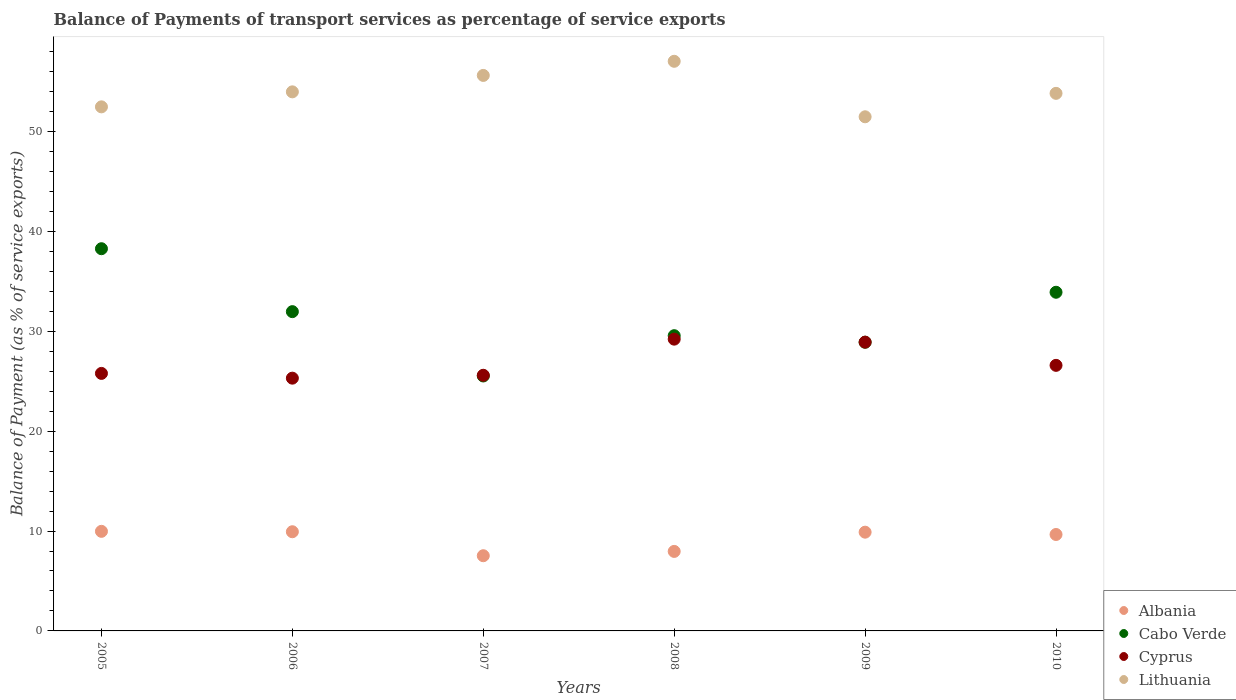How many different coloured dotlines are there?
Ensure brevity in your answer.  4. What is the balance of payments of transport services in Lithuania in 2005?
Offer a terse response. 52.47. Across all years, what is the maximum balance of payments of transport services in Cyprus?
Make the answer very short. 29.21. Across all years, what is the minimum balance of payments of transport services in Albania?
Your answer should be compact. 7.53. In which year was the balance of payments of transport services in Albania minimum?
Offer a very short reply. 2007. What is the total balance of payments of transport services in Cabo Verde in the graph?
Ensure brevity in your answer.  188.13. What is the difference between the balance of payments of transport services in Cyprus in 2006 and that in 2010?
Ensure brevity in your answer.  -1.28. What is the difference between the balance of payments of transport services in Cyprus in 2008 and the balance of payments of transport services in Albania in 2010?
Keep it short and to the point. 19.56. What is the average balance of payments of transport services in Cabo Verde per year?
Your answer should be very brief. 31.35. In the year 2010, what is the difference between the balance of payments of transport services in Cabo Verde and balance of payments of transport services in Cyprus?
Give a very brief answer. 7.32. In how many years, is the balance of payments of transport services in Cyprus greater than 54 %?
Provide a succinct answer. 0. What is the ratio of the balance of payments of transport services in Lithuania in 2005 to that in 2007?
Your answer should be compact. 0.94. Is the balance of payments of transport services in Cyprus in 2006 less than that in 2007?
Your response must be concise. Yes. What is the difference between the highest and the second highest balance of payments of transport services in Albania?
Make the answer very short. 0.04. What is the difference between the highest and the lowest balance of payments of transport services in Albania?
Your answer should be very brief. 2.44. Does the balance of payments of transport services in Lithuania monotonically increase over the years?
Give a very brief answer. No. Is the balance of payments of transport services in Albania strictly greater than the balance of payments of transport services in Cabo Verde over the years?
Your answer should be compact. No. How many dotlines are there?
Make the answer very short. 4. How many years are there in the graph?
Your response must be concise. 6. What is the difference between two consecutive major ticks on the Y-axis?
Your answer should be very brief. 10. Does the graph contain any zero values?
Your response must be concise. No. Does the graph contain grids?
Your answer should be compact. No. How many legend labels are there?
Your answer should be very brief. 4. What is the title of the graph?
Offer a terse response. Balance of Payments of transport services as percentage of service exports. Does "Antigua and Barbuda" appear as one of the legend labels in the graph?
Make the answer very short. No. What is the label or title of the Y-axis?
Offer a very short reply. Balance of Payment (as % of service exports). What is the Balance of Payment (as % of service exports) of Albania in 2005?
Keep it short and to the point. 9.97. What is the Balance of Payment (as % of service exports) of Cabo Verde in 2005?
Offer a very short reply. 38.27. What is the Balance of Payment (as % of service exports) in Cyprus in 2005?
Make the answer very short. 25.78. What is the Balance of Payment (as % of service exports) of Lithuania in 2005?
Keep it short and to the point. 52.47. What is the Balance of Payment (as % of service exports) of Albania in 2006?
Your response must be concise. 9.93. What is the Balance of Payment (as % of service exports) of Cabo Verde in 2006?
Offer a very short reply. 31.97. What is the Balance of Payment (as % of service exports) of Cyprus in 2006?
Make the answer very short. 25.31. What is the Balance of Payment (as % of service exports) of Lithuania in 2006?
Your answer should be very brief. 53.97. What is the Balance of Payment (as % of service exports) in Albania in 2007?
Keep it short and to the point. 7.53. What is the Balance of Payment (as % of service exports) in Cabo Verde in 2007?
Offer a terse response. 25.53. What is the Balance of Payment (as % of service exports) in Cyprus in 2007?
Keep it short and to the point. 25.6. What is the Balance of Payment (as % of service exports) in Lithuania in 2007?
Your response must be concise. 55.62. What is the Balance of Payment (as % of service exports) in Albania in 2008?
Offer a terse response. 7.96. What is the Balance of Payment (as % of service exports) in Cabo Verde in 2008?
Provide a succinct answer. 29.56. What is the Balance of Payment (as % of service exports) of Cyprus in 2008?
Ensure brevity in your answer.  29.21. What is the Balance of Payment (as % of service exports) of Lithuania in 2008?
Offer a terse response. 57.03. What is the Balance of Payment (as % of service exports) in Albania in 2009?
Your answer should be compact. 9.89. What is the Balance of Payment (as % of service exports) of Cabo Verde in 2009?
Provide a short and direct response. 28.9. What is the Balance of Payment (as % of service exports) in Cyprus in 2009?
Keep it short and to the point. 28.91. What is the Balance of Payment (as % of service exports) in Lithuania in 2009?
Your answer should be very brief. 51.48. What is the Balance of Payment (as % of service exports) in Albania in 2010?
Give a very brief answer. 9.65. What is the Balance of Payment (as % of service exports) of Cabo Verde in 2010?
Give a very brief answer. 33.91. What is the Balance of Payment (as % of service exports) in Cyprus in 2010?
Give a very brief answer. 26.59. What is the Balance of Payment (as % of service exports) of Lithuania in 2010?
Give a very brief answer. 53.82. Across all years, what is the maximum Balance of Payment (as % of service exports) in Albania?
Keep it short and to the point. 9.97. Across all years, what is the maximum Balance of Payment (as % of service exports) in Cabo Verde?
Ensure brevity in your answer.  38.27. Across all years, what is the maximum Balance of Payment (as % of service exports) of Cyprus?
Provide a succinct answer. 29.21. Across all years, what is the maximum Balance of Payment (as % of service exports) in Lithuania?
Provide a succinct answer. 57.03. Across all years, what is the minimum Balance of Payment (as % of service exports) in Albania?
Offer a very short reply. 7.53. Across all years, what is the minimum Balance of Payment (as % of service exports) of Cabo Verde?
Keep it short and to the point. 25.53. Across all years, what is the minimum Balance of Payment (as % of service exports) in Cyprus?
Offer a terse response. 25.31. Across all years, what is the minimum Balance of Payment (as % of service exports) in Lithuania?
Offer a terse response. 51.48. What is the total Balance of Payment (as % of service exports) of Albania in the graph?
Give a very brief answer. 54.93. What is the total Balance of Payment (as % of service exports) of Cabo Verde in the graph?
Offer a terse response. 188.13. What is the total Balance of Payment (as % of service exports) in Cyprus in the graph?
Your response must be concise. 161.4. What is the total Balance of Payment (as % of service exports) of Lithuania in the graph?
Offer a terse response. 324.39. What is the difference between the Balance of Payment (as % of service exports) in Albania in 2005 and that in 2006?
Ensure brevity in your answer.  0.04. What is the difference between the Balance of Payment (as % of service exports) in Cabo Verde in 2005 and that in 2006?
Give a very brief answer. 6.3. What is the difference between the Balance of Payment (as % of service exports) of Cyprus in 2005 and that in 2006?
Ensure brevity in your answer.  0.48. What is the difference between the Balance of Payment (as % of service exports) in Lithuania in 2005 and that in 2006?
Offer a very short reply. -1.5. What is the difference between the Balance of Payment (as % of service exports) of Albania in 2005 and that in 2007?
Offer a very short reply. 2.44. What is the difference between the Balance of Payment (as % of service exports) in Cabo Verde in 2005 and that in 2007?
Your answer should be very brief. 12.74. What is the difference between the Balance of Payment (as % of service exports) in Cyprus in 2005 and that in 2007?
Provide a short and direct response. 0.19. What is the difference between the Balance of Payment (as % of service exports) in Lithuania in 2005 and that in 2007?
Offer a terse response. -3.15. What is the difference between the Balance of Payment (as % of service exports) in Albania in 2005 and that in 2008?
Ensure brevity in your answer.  2.01. What is the difference between the Balance of Payment (as % of service exports) in Cabo Verde in 2005 and that in 2008?
Give a very brief answer. 8.71. What is the difference between the Balance of Payment (as % of service exports) of Cyprus in 2005 and that in 2008?
Ensure brevity in your answer.  -3.43. What is the difference between the Balance of Payment (as % of service exports) in Lithuania in 2005 and that in 2008?
Keep it short and to the point. -4.56. What is the difference between the Balance of Payment (as % of service exports) of Albania in 2005 and that in 2009?
Provide a short and direct response. 0.08. What is the difference between the Balance of Payment (as % of service exports) of Cabo Verde in 2005 and that in 2009?
Make the answer very short. 9.36. What is the difference between the Balance of Payment (as % of service exports) of Cyprus in 2005 and that in 2009?
Offer a terse response. -3.13. What is the difference between the Balance of Payment (as % of service exports) of Lithuania in 2005 and that in 2009?
Ensure brevity in your answer.  0.99. What is the difference between the Balance of Payment (as % of service exports) of Albania in 2005 and that in 2010?
Provide a succinct answer. 0.32. What is the difference between the Balance of Payment (as % of service exports) in Cabo Verde in 2005 and that in 2010?
Ensure brevity in your answer.  4.36. What is the difference between the Balance of Payment (as % of service exports) of Cyprus in 2005 and that in 2010?
Your response must be concise. -0.81. What is the difference between the Balance of Payment (as % of service exports) in Lithuania in 2005 and that in 2010?
Provide a succinct answer. -1.35. What is the difference between the Balance of Payment (as % of service exports) of Albania in 2006 and that in 2007?
Make the answer very short. 2.4. What is the difference between the Balance of Payment (as % of service exports) of Cabo Verde in 2006 and that in 2007?
Ensure brevity in your answer.  6.44. What is the difference between the Balance of Payment (as % of service exports) in Cyprus in 2006 and that in 2007?
Your answer should be very brief. -0.29. What is the difference between the Balance of Payment (as % of service exports) in Lithuania in 2006 and that in 2007?
Your answer should be compact. -1.64. What is the difference between the Balance of Payment (as % of service exports) in Albania in 2006 and that in 2008?
Provide a short and direct response. 1.97. What is the difference between the Balance of Payment (as % of service exports) of Cabo Verde in 2006 and that in 2008?
Your answer should be very brief. 2.41. What is the difference between the Balance of Payment (as % of service exports) in Cyprus in 2006 and that in 2008?
Make the answer very short. -3.91. What is the difference between the Balance of Payment (as % of service exports) of Lithuania in 2006 and that in 2008?
Make the answer very short. -3.06. What is the difference between the Balance of Payment (as % of service exports) in Albania in 2006 and that in 2009?
Provide a succinct answer. 0.04. What is the difference between the Balance of Payment (as % of service exports) of Cabo Verde in 2006 and that in 2009?
Provide a succinct answer. 3.06. What is the difference between the Balance of Payment (as % of service exports) of Cyprus in 2006 and that in 2009?
Provide a short and direct response. -3.61. What is the difference between the Balance of Payment (as % of service exports) in Lithuania in 2006 and that in 2009?
Provide a short and direct response. 2.5. What is the difference between the Balance of Payment (as % of service exports) in Albania in 2006 and that in 2010?
Your answer should be very brief. 0.28. What is the difference between the Balance of Payment (as % of service exports) of Cabo Verde in 2006 and that in 2010?
Provide a succinct answer. -1.94. What is the difference between the Balance of Payment (as % of service exports) of Cyprus in 2006 and that in 2010?
Keep it short and to the point. -1.28. What is the difference between the Balance of Payment (as % of service exports) in Lithuania in 2006 and that in 2010?
Ensure brevity in your answer.  0.15. What is the difference between the Balance of Payment (as % of service exports) in Albania in 2007 and that in 2008?
Your answer should be compact. -0.43. What is the difference between the Balance of Payment (as % of service exports) of Cabo Verde in 2007 and that in 2008?
Provide a short and direct response. -4.03. What is the difference between the Balance of Payment (as % of service exports) in Cyprus in 2007 and that in 2008?
Give a very brief answer. -3.62. What is the difference between the Balance of Payment (as % of service exports) in Lithuania in 2007 and that in 2008?
Provide a short and direct response. -1.41. What is the difference between the Balance of Payment (as % of service exports) in Albania in 2007 and that in 2009?
Your response must be concise. -2.36. What is the difference between the Balance of Payment (as % of service exports) of Cabo Verde in 2007 and that in 2009?
Provide a short and direct response. -3.38. What is the difference between the Balance of Payment (as % of service exports) in Cyprus in 2007 and that in 2009?
Give a very brief answer. -3.32. What is the difference between the Balance of Payment (as % of service exports) in Lithuania in 2007 and that in 2009?
Offer a terse response. 4.14. What is the difference between the Balance of Payment (as % of service exports) of Albania in 2007 and that in 2010?
Provide a succinct answer. -2.13. What is the difference between the Balance of Payment (as % of service exports) of Cabo Verde in 2007 and that in 2010?
Provide a succinct answer. -8.38. What is the difference between the Balance of Payment (as % of service exports) of Cyprus in 2007 and that in 2010?
Your answer should be compact. -0.99. What is the difference between the Balance of Payment (as % of service exports) of Lithuania in 2007 and that in 2010?
Offer a terse response. 1.79. What is the difference between the Balance of Payment (as % of service exports) in Albania in 2008 and that in 2009?
Offer a terse response. -1.93. What is the difference between the Balance of Payment (as % of service exports) in Cabo Verde in 2008 and that in 2009?
Keep it short and to the point. 0.66. What is the difference between the Balance of Payment (as % of service exports) of Cyprus in 2008 and that in 2009?
Offer a very short reply. 0.3. What is the difference between the Balance of Payment (as % of service exports) in Lithuania in 2008 and that in 2009?
Provide a short and direct response. 5.56. What is the difference between the Balance of Payment (as % of service exports) of Albania in 2008 and that in 2010?
Your response must be concise. -1.69. What is the difference between the Balance of Payment (as % of service exports) in Cabo Verde in 2008 and that in 2010?
Ensure brevity in your answer.  -4.35. What is the difference between the Balance of Payment (as % of service exports) of Cyprus in 2008 and that in 2010?
Your response must be concise. 2.62. What is the difference between the Balance of Payment (as % of service exports) in Lithuania in 2008 and that in 2010?
Offer a terse response. 3.21. What is the difference between the Balance of Payment (as % of service exports) of Albania in 2009 and that in 2010?
Offer a very short reply. 0.23. What is the difference between the Balance of Payment (as % of service exports) of Cabo Verde in 2009 and that in 2010?
Your answer should be compact. -5.01. What is the difference between the Balance of Payment (as % of service exports) in Cyprus in 2009 and that in 2010?
Your answer should be very brief. 2.32. What is the difference between the Balance of Payment (as % of service exports) in Lithuania in 2009 and that in 2010?
Offer a terse response. -2.35. What is the difference between the Balance of Payment (as % of service exports) of Albania in 2005 and the Balance of Payment (as % of service exports) of Cabo Verde in 2006?
Make the answer very short. -22. What is the difference between the Balance of Payment (as % of service exports) in Albania in 2005 and the Balance of Payment (as % of service exports) in Cyprus in 2006?
Keep it short and to the point. -15.34. What is the difference between the Balance of Payment (as % of service exports) of Albania in 2005 and the Balance of Payment (as % of service exports) of Lithuania in 2006?
Your answer should be very brief. -44. What is the difference between the Balance of Payment (as % of service exports) of Cabo Verde in 2005 and the Balance of Payment (as % of service exports) of Cyprus in 2006?
Your answer should be very brief. 12.96. What is the difference between the Balance of Payment (as % of service exports) in Cabo Verde in 2005 and the Balance of Payment (as % of service exports) in Lithuania in 2006?
Offer a very short reply. -15.71. What is the difference between the Balance of Payment (as % of service exports) of Cyprus in 2005 and the Balance of Payment (as % of service exports) of Lithuania in 2006?
Make the answer very short. -28.19. What is the difference between the Balance of Payment (as % of service exports) of Albania in 2005 and the Balance of Payment (as % of service exports) of Cabo Verde in 2007?
Offer a very short reply. -15.55. What is the difference between the Balance of Payment (as % of service exports) in Albania in 2005 and the Balance of Payment (as % of service exports) in Cyprus in 2007?
Provide a succinct answer. -15.63. What is the difference between the Balance of Payment (as % of service exports) of Albania in 2005 and the Balance of Payment (as % of service exports) of Lithuania in 2007?
Keep it short and to the point. -45.65. What is the difference between the Balance of Payment (as % of service exports) in Cabo Verde in 2005 and the Balance of Payment (as % of service exports) in Cyprus in 2007?
Your answer should be compact. 12.67. What is the difference between the Balance of Payment (as % of service exports) in Cabo Verde in 2005 and the Balance of Payment (as % of service exports) in Lithuania in 2007?
Provide a succinct answer. -17.35. What is the difference between the Balance of Payment (as % of service exports) in Cyprus in 2005 and the Balance of Payment (as % of service exports) in Lithuania in 2007?
Offer a very short reply. -29.83. What is the difference between the Balance of Payment (as % of service exports) in Albania in 2005 and the Balance of Payment (as % of service exports) in Cabo Verde in 2008?
Ensure brevity in your answer.  -19.59. What is the difference between the Balance of Payment (as % of service exports) of Albania in 2005 and the Balance of Payment (as % of service exports) of Cyprus in 2008?
Give a very brief answer. -19.24. What is the difference between the Balance of Payment (as % of service exports) in Albania in 2005 and the Balance of Payment (as % of service exports) in Lithuania in 2008?
Offer a very short reply. -47.06. What is the difference between the Balance of Payment (as % of service exports) in Cabo Verde in 2005 and the Balance of Payment (as % of service exports) in Cyprus in 2008?
Keep it short and to the point. 9.05. What is the difference between the Balance of Payment (as % of service exports) of Cabo Verde in 2005 and the Balance of Payment (as % of service exports) of Lithuania in 2008?
Offer a very short reply. -18.76. What is the difference between the Balance of Payment (as % of service exports) in Cyprus in 2005 and the Balance of Payment (as % of service exports) in Lithuania in 2008?
Make the answer very short. -31.25. What is the difference between the Balance of Payment (as % of service exports) in Albania in 2005 and the Balance of Payment (as % of service exports) in Cabo Verde in 2009?
Your answer should be compact. -18.93. What is the difference between the Balance of Payment (as % of service exports) of Albania in 2005 and the Balance of Payment (as % of service exports) of Cyprus in 2009?
Give a very brief answer. -18.94. What is the difference between the Balance of Payment (as % of service exports) in Albania in 2005 and the Balance of Payment (as % of service exports) in Lithuania in 2009?
Give a very brief answer. -41.51. What is the difference between the Balance of Payment (as % of service exports) of Cabo Verde in 2005 and the Balance of Payment (as % of service exports) of Cyprus in 2009?
Give a very brief answer. 9.35. What is the difference between the Balance of Payment (as % of service exports) in Cabo Verde in 2005 and the Balance of Payment (as % of service exports) in Lithuania in 2009?
Give a very brief answer. -13.21. What is the difference between the Balance of Payment (as % of service exports) in Cyprus in 2005 and the Balance of Payment (as % of service exports) in Lithuania in 2009?
Your answer should be very brief. -25.69. What is the difference between the Balance of Payment (as % of service exports) in Albania in 2005 and the Balance of Payment (as % of service exports) in Cabo Verde in 2010?
Provide a succinct answer. -23.94. What is the difference between the Balance of Payment (as % of service exports) in Albania in 2005 and the Balance of Payment (as % of service exports) in Cyprus in 2010?
Make the answer very short. -16.62. What is the difference between the Balance of Payment (as % of service exports) in Albania in 2005 and the Balance of Payment (as % of service exports) in Lithuania in 2010?
Your answer should be very brief. -43.85. What is the difference between the Balance of Payment (as % of service exports) in Cabo Verde in 2005 and the Balance of Payment (as % of service exports) in Cyprus in 2010?
Provide a short and direct response. 11.68. What is the difference between the Balance of Payment (as % of service exports) of Cabo Verde in 2005 and the Balance of Payment (as % of service exports) of Lithuania in 2010?
Ensure brevity in your answer.  -15.56. What is the difference between the Balance of Payment (as % of service exports) of Cyprus in 2005 and the Balance of Payment (as % of service exports) of Lithuania in 2010?
Provide a succinct answer. -28.04. What is the difference between the Balance of Payment (as % of service exports) of Albania in 2006 and the Balance of Payment (as % of service exports) of Cabo Verde in 2007?
Your answer should be compact. -15.6. What is the difference between the Balance of Payment (as % of service exports) of Albania in 2006 and the Balance of Payment (as % of service exports) of Cyprus in 2007?
Provide a short and direct response. -15.67. What is the difference between the Balance of Payment (as % of service exports) of Albania in 2006 and the Balance of Payment (as % of service exports) of Lithuania in 2007?
Offer a very short reply. -45.69. What is the difference between the Balance of Payment (as % of service exports) of Cabo Verde in 2006 and the Balance of Payment (as % of service exports) of Cyprus in 2007?
Provide a succinct answer. 6.37. What is the difference between the Balance of Payment (as % of service exports) of Cabo Verde in 2006 and the Balance of Payment (as % of service exports) of Lithuania in 2007?
Your answer should be very brief. -23.65. What is the difference between the Balance of Payment (as % of service exports) in Cyprus in 2006 and the Balance of Payment (as % of service exports) in Lithuania in 2007?
Keep it short and to the point. -30.31. What is the difference between the Balance of Payment (as % of service exports) in Albania in 2006 and the Balance of Payment (as % of service exports) in Cabo Verde in 2008?
Give a very brief answer. -19.63. What is the difference between the Balance of Payment (as % of service exports) in Albania in 2006 and the Balance of Payment (as % of service exports) in Cyprus in 2008?
Keep it short and to the point. -19.28. What is the difference between the Balance of Payment (as % of service exports) in Albania in 2006 and the Balance of Payment (as % of service exports) in Lithuania in 2008?
Offer a very short reply. -47.1. What is the difference between the Balance of Payment (as % of service exports) in Cabo Verde in 2006 and the Balance of Payment (as % of service exports) in Cyprus in 2008?
Keep it short and to the point. 2.75. What is the difference between the Balance of Payment (as % of service exports) of Cabo Verde in 2006 and the Balance of Payment (as % of service exports) of Lithuania in 2008?
Provide a short and direct response. -25.07. What is the difference between the Balance of Payment (as % of service exports) of Cyprus in 2006 and the Balance of Payment (as % of service exports) of Lithuania in 2008?
Keep it short and to the point. -31.72. What is the difference between the Balance of Payment (as % of service exports) of Albania in 2006 and the Balance of Payment (as % of service exports) of Cabo Verde in 2009?
Offer a terse response. -18.97. What is the difference between the Balance of Payment (as % of service exports) in Albania in 2006 and the Balance of Payment (as % of service exports) in Cyprus in 2009?
Your answer should be compact. -18.98. What is the difference between the Balance of Payment (as % of service exports) in Albania in 2006 and the Balance of Payment (as % of service exports) in Lithuania in 2009?
Your response must be concise. -41.55. What is the difference between the Balance of Payment (as % of service exports) in Cabo Verde in 2006 and the Balance of Payment (as % of service exports) in Cyprus in 2009?
Your answer should be compact. 3.05. What is the difference between the Balance of Payment (as % of service exports) in Cabo Verde in 2006 and the Balance of Payment (as % of service exports) in Lithuania in 2009?
Provide a short and direct response. -19.51. What is the difference between the Balance of Payment (as % of service exports) in Cyprus in 2006 and the Balance of Payment (as % of service exports) in Lithuania in 2009?
Provide a succinct answer. -26.17. What is the difference between the Balance of Payment (as % of service exports) in Albania in 2006 and the Balance of Payment (as % of service exports) in Cabo Verde in 2010?
Offer a terse response. -23.98. What is the difference between the Balance of Payment (as % of service exports) of Albania in 2006 and the Balance of Payment (as % of service exports) of Cyprus in 2010?
Provide a short and direct response. -16.66. What is the difference between the Balance of Payment (as % of service exports) of Albania in 2006 and the Balance of Payment (as % of service exports) of Lithuania in 2010?
Make the answer very short. -43.89. What is the difference between the Balance of Payment (as % of service exports) of Cabo Verde in 2006 and the Balance of Payment (as % of service exports) of Cyprus in 2010?
Offer a very short reply. 5.38. What is the difference between the Balance of Payment (as % of service exports) in Cabo Verde in 2006 and the Balance of Payment (as % of service exports) in Lithuania in 2010?
Give a very brief answer. -21.86. What is the difference between the Balance of Payment (as % of service exports) in Cyprus in 2006 and the Balance of Payment (as % of service exports) in Lithuania in 2010?
Keep it short and to the point. -28.52. What is the difference between the Balance of Payment (as % of service exports) in Albania in 2007 and the Balance of Payment (as % of service exports) in Cabo Verde in 2008?
Offer a terse response. -22.03. What is the difference between the Balance of Payment (as % of service exports) in Albania in 2007 and the Balance of Payment (as % of service exports) in Cyprus in 2008?
Provide a succinct answer. -21.68. What is the difference between the Balance of Payment (as % of service exports) in Albania in 2007 and the Balance of Payment (as % of service exports) in Lithuania in 2008?
Offer a terse response. -49.5. What is the difference between the Balance of Payment (as % of service exports) of Cabo Verde in 2007 and the Balance of Payment (as % of service exports) of Cyprus in 2008?
Your answer should be compact. -3.69. What is the difference between the Balance of Payment (as % of service exports) of Cabo Verde in 2007 and the Balance of Payment (as % of service exports) of Lithuania in 2008?
Your answer should be compact. -31.51. What is the difference between the Balance of Payment (as % of service exports) in Cyprus in 2007 and the Balance of Payment (as % of service exports) in Lithuania in 2008?
Ensure brevity in your answer.  -31.44. What is the difference between the Balance of Payment (as % of service exports) of Albania in 2007 and the Balance of Payment (as % of service exports) of Cabo Verde in 2009?
Provide a short and direct response. -21.37. What is the difference between the Balance of Payment (as % of service exports) of Albania in 2007 and the Balance of Payment (as % of service exports) of Cyprus in 2009?
Keep it short and to the point. -21.38. What is the difference between the Balance of Payment (as % of service exports) of Albania in 2007 and the Balance of Payment (as % of service exports) of Lithuania in 2009?
Provide a succinct answer. -43.95. What is the difference between the Balance of Payment (as % of service exports) in Cabo Verde in 2007 and the Balance of Payment (as % of service exports) in Cyprus in 2009?
Your answer should be very brief. -3.39. What is the difference between the Balance of Payment (as % of service exports) in Cabo Verde in 2007 and the Balance of Payment (as % of service exports) in Lithuania in 2009?
Make the answer very short. -25.95. What is the difference between the Balance of Payment (as % of service exports) of Cyprus in 2007 and the Balance of Payment (as % of service exports) of Lithuania in 2009?
Keep it short and to the point. -25.88. What is the difference between the Balance of Payment (as % of service exports) of Albania in 2007 and the Balance of Payment (as % of service exports) of Cabo Verde in 2010?
Offer a very short reply. -26.38. What is the difference between the Balance of Payment (as % of service exports) in Albania in 2007 and the Balance of Payment (as % of service exports) in Cyprus in 2010?
Your response must be concise. -19.06. What is the difference between the Balance of Payment (as % of service exports) in Albania in 2007 and the Balance of Payment (as % of service exports) in Lithuania in 2010?
Your answer should be compact. -46.29. What is the difference between the Balance of Payment (as % of service exports) of Cabo Verde in 2007 and the Balance of Payment (as % of service exports) of Cyprus in 2010?
Keep it short and to the point. -1.06. What is the difference between the Balance of Payment (as % of service exports) in Cabo Verde in 2007 and the Balance of Payment (as % of service exports) in Lithuania in 2010?
Make the answer very short. -28.3. What is the difference between the Balance of Payment (as % of service exports) of Cyprus in 2007 and the Balance of Payment (as % of service exports) of Lithuania in 2010?
Offer a terse response. -28.23. What is the difference between the Balance of Payment (as % of service exports) in Albania in 2008 and the Balance of Payment (as % of service exports) in Cabo Verde in 2009?
Your answer should be compact. -20.94. What is the difference between the Balance of Payment (as % of service exports) of Albania in 2008 and the Balance of Payment (as % of service exports) of Cyprus in 2009?
Give a very brief answer. -20.95. What is the difference between the Balance of Payment (as % of service exports) of Albania in 2008 and the Balance of Payment (as % of service exports) of Lithuania in 2009?
Your answer should be very brief. -43.52. What is the difference between the Balance of Payment (as % of service exports) in Cabo Verde in 2008 and the Balance of Payment (as % of service exports) in Cyprus in 2009?
Your response must be concise. 0.65. What is the difference between the Balance of Payment (as % of service exports) of Cabo Verde in 2008 and the Balance of Payment (as % of service exports) of Lithuania in 2009?
Offer a very short reply. -21.92. What is the difference between the Balance of Payment (as % of service exports) of Cyprus in 2008 and the Balance of Payment (as % of service exports) of Lithuania in 2009?
Your response must be concise. -22.26. What is the difference between the Balance of Payment (as % of service exports) in Albania in 2008 and the Balance of Payment (as % of service exports) in Cabo Verde in 2010?
Ensure brevity in your answer.  -25.95. What is the difference between the Balance of Payment (as % of service exports) of Albania in 2008 and the Balance of Payment (as % of service exports) of Cyprus in 2010?
Keep it short and to the point. -18.63. What is the difference between the Balance of Payment (as % of service exports) of Albania in 2008 and the Balance of Payment (as % of service exports) of Lithuania in 2010?
Make the answer very short. -45.86. What is the difference between the Balance of Payment (as % of service exports) in Cabo Verde in 2008 and the Balance of Payment (as % of service exports) in Cyprus in 2010?
Your answer should be compact. 2.97. What is the difference between the Balance of Payment (as % of service exports) of Cabo Verde in 2008 and the Balance of Payment (as % of service exports) of Lithuania in 2010?
Your response must be concise. -24.26. What is the difference between the Balance of Payment (as % of service exports) of Cyprus in 2008 and the Balance of Payment (as % of service exports) of Lithuania in 2010?
Provide a succinct answer. -24.61. What is the difference between the Balance of Payment (as % of service exports) in Albania in 2009 and the Balance of Payment (as % of service exports) in Cabo Verde in 2010?
Provide a succinct answer. -24.02. What is the difference between the Balance of Payment (as % of service exports) in Albania in 2009 and the Balance of Payment (as % of service exports) in Cyprus in 2010?
Your answer should be compact. -16.7. What is the difference between the Balance of Payment (as % of service exports) in Albania in 2009 and the Balance of Payment (as % of service exports) in Lithuania in 2010?
Give a very brief answer. -43.94. What is the difference between the Balance of Payment (as % of service exports) of Cabo Verde in 2009 and the Balance of Payment (as % of service exports) of Cyprus in 2010?
Offer a terse response. 2.31. What is the difference between the Balance of Payment (as % of service exports) of Cabo Verde in 2009 and the Balance of Payment (as % of service exports) of Lithuania in 2010?
Keep it short and to the point. -24.92. What is the difference between the Balance of Payment (as % of service exports) in Cyprus in 2009 and the Balance of Payment (as % of service exports) in Lithuania in 2010?
Your answer should be very brief. -24.91. What is the average Balance of Payment (as % of service exports) of Albania per year?
Give a very brief answer. 9.16. What is the average Balance of Payment (as % of service exports) of Cabo Verde per year?
Provide a succinct answer. 31.35. What is the average Balance of Payment (as % of service exports) in Cyprus per year?
Offer a very short reply. 26.9. What is the average Balance of Payment (as % of service exports) of Lithuania per year?
Make the answer very short. 54.07. In the year 2005, what is the difference between the Balance of Payment (as % of service exports) in Albania and Balance of Payment (as % of service exports) in Cabo Verde?
Offer a very short reply. -28.3. In the year 2005, what is the difference between the Balance of Payment (as % of service exports) in Albania and Balance of Payment (as % of service exports) in Cyprus?
Offer a very short reply. -15.81. In the year 2005, what is the difference between the Balance of Payment (as % of service exports) in Albania and Balance of Payment (as % of service exports) in Lithuania?
Give a very brief answer. -42.5. In the year 2005, what is the difference between the Balance of Payment (as % of service exports) of Cabo Verde and Balance of Payment (as % of service exports) of Cyprus?
Provide a short and direct response. 12.48. In the year 2005, what is the difference between the Balance of Payment (as % of service exports) in Cabo Verde and Balance of Payment (as % of service exports) in Lithuania?
Give a very brief answer. -14.2. In the year 2005, what is the difference between the Balance of Payment (as % of service exports) in Cyprus and Balance of Payment (as % of service exports) in Lithuania?
Offer a terse response. -26.69. In the year 2006, what is the difference between the Balance of Payment (as % of service exports) in Albania and Balance of Payment (as % of service exports) in Cabo Verde?
Your answer should be very brief. -22.04. In the year 2006, what is the difference between the Balance of Payment (as % of service exports) of Albania and Balance of Payment (as % of service exports) of Cyprus?
Your answer should be compact. -15.38. In the year 2006, what is the difference between the Balance of Payment (as % of service exports) of Albania and Balance of Payment (as % of service exports) of Lithuania?
Give a very brief answer. -44.04. In the year 2006, what is the difference between the Balance of Payment (as % of service exports) of Cabo Verde and Balance of Payment (as % of service exports) of Cyprus?
Keep it short and to the point. 6.66. In the year 2006, what is the difference between the Balance of Payment (as % of service exports) in Cabo Verde and Balance of Payment (as % of service exports) in Lithuania?
Your answer should be very brief. -22.01. In the year 2006, what is the difference between the Balance of Payment (as % of service exports) in Cyprus and Balance of Payment (as % of service exports) in Lithuania?
Offer a terse response. -28.67. In the year 2007, what is the difference between the Balance of Payment (as % of service exports) of Albania and Balance of Payment (as % of service exports) of Cabo Verde?
Provide a succinct answer. -18. In the year 2007, what is the difference between the Balance of Payment (as % of service exports) of Albania and Balance of Payment (as % of service exports) of Cyprus?
Offer a terse response. -18.07. In the year 2007, what is the difference between the Balance of Payment (as % of service exports) in Albania and Balance of Payment (as % of service exports) in Lithuania?
Your response must be concise. -48.09. In the year 2007, what is the difference between the Balance of Payment (as % of service exports) in Cabo Verde and Balance of Payment (as % of service exports) in Cyprus?
Provide a succinct answer. -0.07. In the year 2007, what is the difference between the Balance of Payment (as % of service exports) of Cabo Verde and Balance of Payment (as % of service exports) of Lithuania?
Provide a short and direct response. -30.09. In the year 2007, what is the difference between the Balance of Payment (as % of service exports) in Cyprus and Balance of Payment (as % of service exports) in Lithuania?
Your response must be concise. -30.02. In the year 2008, what is the difference between the Balance of Payment (as % of service exports) in Albania and Balance of Payment (as % of service exports) in Cabo Verde?
Provide a succinct answer. -21.6. In the year 2008, what is the difference between the Balance of Payment (as % of service exports) in Albania and Balance of Payment (as % of service exports) in Cyprus?
Your answer should be very brief. -21.25. In the year 2008, what is the difference between the Balance of Payment (as % of service exports) in Albania and Balance of Payment (as % of service exports) in Lithuania?
Offer a terse response. -49.07. In the year 2008, what is the difference between the Balance of Payment (as % of service exports) in Cabo Verde and Balance of Payment (as % of service exports) in Cyprus?
Your answer should be very brief. 0.35. In the year 2008, what is the difference between the Balance of Payment (as % of service exports) of Cabo Verde and Balance of Payment (as % of service exports) of Lithuania?
Ensure brevity in your answer.  -27.47. In the year 2008, what is the difference between the Balance of Payment (as % of service exports) of Cyprus and Balance of Payment (as % of service exports) of Lithuania?
Offer a terse response. -27.82. In the year 2009, what is the difference between the Balance of Payment (as % of service exports) in Albania and Balance of Payment (as % of service exports) in Cabo Verde?
Ensure brevity in your answer.  -19.02. In the year 2009, what is the difference between the Balance of Payment (as % of service exports) of Albania and Balance of Payment (as % of service exports) of Cyprus?
Offer a terse response. -19.03. In the year 2009, what is the difference between the Balance of Payment (as % of service exports) in Albania and Balance of Payment (as % of service exports) in Lithuania?
Offer a terse response. -41.59. In the year 2009, what is the difference between the Balance of Payment (as % of service exports) in Cabo Verde and Balance of Payment (as % of service exports) in Cyprus?
Offer a terse response. -0.01. In the year 2009, what is the difference between the Balance of Payment (as % of service exports) in Cabo Verde and Balance of Payment (as % of service exports) in Lithuania?
Provide a succinct answer. -22.57. In the year 2009, what is the difference between the Balance of Payment (as % of service exports) in Cyprus and Balance of Payment (as % of service exports) in Lithuania?
Offer a terse response. -22.56. In the year 2010, what is the difference between the Balance of Payment (as % of service exports) in Albania and Balance of Payment (as % of service exports) in Cabo Verde?
Make the answer very short. -24.25. In the year 2010, what is the difference between the Balance of Payment (as % of service exports) of Albania and Balance of Payment (as % of service exports) of Cyprus?
Offer a very short reply. -16.93. In the year 2010, what is the difference between the Balance of Payment (as % of service exports) in Albania and Balance of Payment (as % of service exports) in Lithuania?
Keep it short and to the point. -44.17. In the year 2010, what is the difference between the Balance of Payment (as % of service exports) of Cabo Verde and Balance of Payment (as % of service exports) of Cyprus?
Give a very brief answer. 7.32. In the year 2010, what is the difference between the Balance of Payment (as % of service exports) of Cabo Verde and Balance of Payment (as % of service exports) of Lithuania?
Ensure brevity in your answer.  -19.91. In the year 2010, what is the difference between the Balance of Payment (as % of service exports) in Cyprus and Balance of Payment (as % of service exports) in Lithuania?
Keep it short and to the point. -27.23. What is the ratio of the Balance of Payment (as % of service exports) of Albania in 2005 to that in 2006?
Your answer should be very brief. 1. What is the ratio of the Balance of Payment (as % of service exports) in Cabo Verde in 2005 to that in 2006?
Provide a succinct answer. 1.2. What is the ratio of the Balance of Payment (as % of service exports) of Cyprus in 2005 to that in 2006?
Provide a short and direct response. 1.02. What is the ratio of the Balance of Payment (as % of service exports) of Lithuania in 2005 to that in 2006?
Make the answer very short. 0.97. What is the ratio of the Balance of Payment (as % of service exports) of Albania in 2005 to that in 2007?
Provide a succinct answer. 1.32. What is the ratio of the Balance of Payment (as % of service exports) of Cabo Verde in 2005 to that in 2007?
Provide a short and direct response. 1.5. What is the ratio of the Balance of Payment (as % of service exports) in Cyprus in 2005 to that in 2007?
Offer a very short reply. 1.01. What is the ratio of the Balance of Payment (as % of service exports) in Lithuania in 2005 to that in 2007?
Your response must be concise. 0.94. What is the ratio of the Balance of Payment (as % of service exports) in Albania in 2005 to that in 2008?
Offer a very short reply. 1.25. What is the ratio of the Balance of Payment (as % of service exports) of Cabo Verde in 2005 to that in 2008?
Give a very brief answer. 1.29. What is the ratio of the Balance of Payment (as % of service exports) of Cyprus in 2005 to that in 2008?
Your answer should be compact. 0.88. What is the ratio of the Balance of Payment (as % of service exports) of Lithuania in 2005 to that in 2008?
Offer a terse response. 0.92. What is the ratio of the Balance of Payment (as % of service exports) in Albania in 2005 to that in 2009?
Offer a terse response. 1.01. What is the ratio of the Balance of Payment (as % of service exports) of Cabo Verde in 2005 to that in 2009?
Provide a succinct answer. 1.32. What is the ratio of the Balance of Payment (as % of service exports) in Cyprus in 2005 to that in 2009?
Make the answer very short. 0.89. What is the ratio of the Balance of Payment (as % of service exports) in Lithuania in 2005 to that in 2009?
Provide a succinct answer. 1.02. What is the ratio of the Balance of Payment (as % of service exports) of Albania in 2005 to that in 2010?
Offer a terse response. 1.03. What is the ratio of the Balance of Payment (as % of service exports) of Cabo Verde in 2005 to that in 2010?
Offer a terse response. 1.13. What is the ratio of the Balance of Payment (as % of service exports) of Cyprus in 2005 to that in 2010?
Keep it short and to the point. 0.97. What is the ratio of the Balance of Payment (as % of service exports) of Lithuania in 2005 to that in 2010?
Your answer should be very brief. 0.97. What is the ratio of the Balance of Payment (as % of service exports) of Albania in 2006 to that in 2007?
Ensure brevity in your answer.  1.32. What is the ratio of the Balance of Payment (as % of service exports) in Cabo Verde in 2006 to that in 2007?
Provide a short and direct response. 1.25. What is the ratio of the Balance of Payment (as % of service exports) in Cyprus in 2006 to that in 2007?
Make the answer very short. 0.99. What is the ratio of the Balance of Payment (as % of service exports) of Lithuania in 2006 to that in 2007?
Make the answer very short. 0.97. What is the ratio of the Balance of Payment (as % of service exports) in Albania in 2006 to that in 2008?
Your answer should be compact. 1.25. What is the ratio of the Balance of Payment (as % of service exports) in Cabo Verde in 2006 to that in 2008?
Your answer should be compact. 1.08. What is the ratio of the Balance of Payment (as % of service exports) of Cyprus in 2006 to that in 2008?
Keep it short and to the point. 0.87. What is the ratio of the Balance of Payment (as % of service exports) of Lithuania in 2006 to that in 2008?
Make the answer very short. 0.95. What is the ratio of the Balance of Payment (as % of service exports) of Cabo Verde in 2006 to that in 2009?
Your answer should be compact. 1.11. What is the ratio of the Balance of Payment (as % of service exports) in Cyprus in 2006 to that in 2009?
Your answer should be compact. 0.88. What is the ratio of the Balance of Payment (as % of service exports) of Lithuania in 2006 to that in 2009?
Your answer should be very brief. 1.05. What is the ratio of the Balance of Payment (as % of service exports) in Albania in 2006 to that in 2010?
Ensure brevity in your answer.  1.03. What is the ratio of the Balance of Payment (as % of service exports) of Cabo Verde in 2006 to that in 2010?
Give a very brief answer. 0.94. What is the ratio of the Balance of Payment (as % of service exports) in Cyprus in 2006 to that in 2010?
Your answer should be compact. 0.95. What is the ratio of the Balance of Payment (as % of service exports) of Lithuania in 2006 to that in 2010?
Your answer should be very brief. 1. What is the ratio of the Balance of Payment (as % of service exports) of Albania in 2007 to that in 2008?
Ensure brevity in your answer.  0.95. What is the ratio of the Balance of Payment (as % of service exports) of Cabo Verde in 2007 to that in 2008?
Offer a very short reply. 0.86. What is the ratio of the Balance of Payment (as % of service exports) in Cyprus in 2007 to that in 2008?
Give a very brief answer. 0.88. What is the ratio of the Balance of Payment (as % of service exports) in Lithuania in 2007 to that in 2008?
Your answer should be compact. 0.98. What is the ratio of the Balance of Payment (as % of service exports) in Albania in 2007 to that in 2009?
Your answer should be very brief. 0.76. What is the ratio of the Balance of Payment (as % of service exports) in Cabo Verde in 2007 to that in 2009?
Provide a succinct answer. 0.88. What is the ratio of the Balance of Payment (as % of service exports) of Cyprus in 2007 to that in 2009?
Provide a succinct answer. 0.89. What is the ratio of the Balance of Payment (as % of service exports) in Lithuania in 2007 to that in 2009?
Provide a short and direct response. 1.08. What is the ratio of the Balance of Payment (as % of service exports) in Albania in 2007 to that in 2010?
Ensure brevity in your answer.  0.78. What is the ratio of the Balance of Payment (as % of service exports) in Cabo Verde in 2007 to that in 2010?
Give a very brief answer. 0.75. What is the ratio of the Balance of Payment (as % of service exports) of Cyprus in 2007 to that in 2010?
Provide a succinct answer. 0.96. What is the ratio of the Balance of Payment (as % of service exports) in Albania in 2008 to that in 2009?
Keep it short and to the point. 0.81. What is the ratio of the Balance of Payment (as % of service exports) in Cabo Verde in 2008 to that in 2009?
Offer a terse response. 1.02. What is the ratio of the Balance of Payment (as % of service exports) of Cyprus in 2008 to that in 2009?
Your response must be concise. 1.01. What is the ratio of the Balance of Payment (as % of service exports) in Lithuania in 2008 to that in 2009?
Your answer should be compact. 1.11. What is the ratio of the Balance of Payment (as % of service exports) in Albania in 2008 to that in 2010?
Offer a very short reply. 0.82. What is the ratio of the Balance of Payment (as % of service exports) of Cabo Verde in 2008 to that in 2010?
Offer a terse response. 0.87. What is the ratio of the Balance of Payment (as % of service exports) of Cyprus in 2008 to that in 2010?
Make the answer very short. 1.1. What is the ratio of the Balance of Payment (as % of service exports) of Lithuania in 2008 to that in 2010?
Make the answer very short. 1.06. What is the ratio of the Balance of Payment (as % of service exports) in Albania in 2009 to that in 2010?
Offer a terse response. 1.02. What is the ratio of the Balance of Payment (as % of service exports) of Cabo Verde in 2009 to that in 2010?
Offer a very short reply. 0.85. What is the ratio of the Balance of Payment (as % of service exports) in Cyprus in 2009 to that in 2010?
Keep it short and to the point. 1.09. What is the ratio of the Balance of Payment (as % of service exports) in Lithuania in 2009 to that in 2010?
Provide a short and direct response. 0.96. What is the difference between the highest and the second highest Balance of Payment (as % of service exports) of Albania?
Make the answer very short. 0.04. What is the difference between the highest and the second highest Balance of Payment (as % of service exports) in Cabo Verde?
Give a very brief answer. 4.36. What is the difference between the highest and the second highest Balance of Payment (as % of service exports) of Cyprus?
Keep it short and to the point. 0.3. What is the difference between the highest and the second highest Balance of Payment (as % of service exports) of Lithuania?
Offer a very short reply. 1.41. What is the difference between the highest and the lowest Balance of Payment (as % of service exports) in Albania?
Keep it short and to the point. 2.44. What is the difference between the highest and the lowest Balance of Payment (as % of service exports) of Cabo Verde?
Your answer should be very brief. 12.74. What is the difference between the highest and the lowest Balance of Payment (as % of service exports) in Cyprus?
Ensure brevity in your answer.  3.91. What is the difference between the highest and the lowest Balance of Payment (as % of service exports) in Lithuania?
Your answer should be very brief. 5.56. 